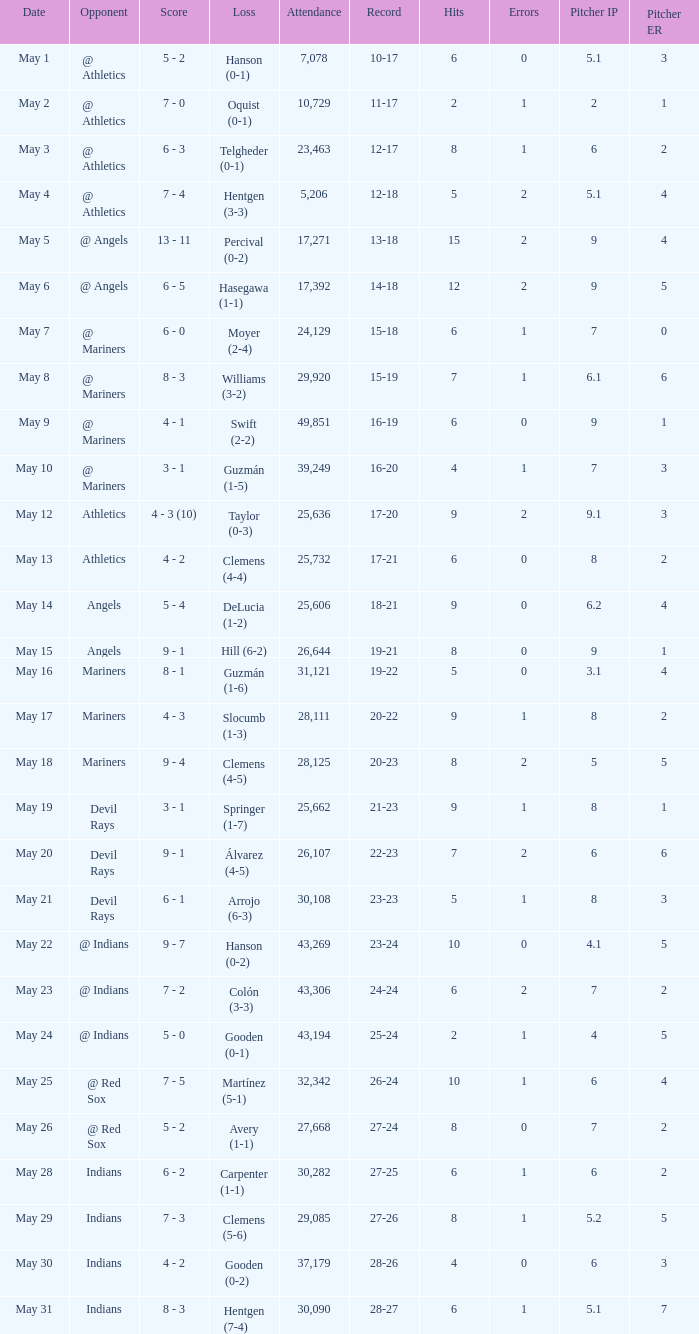What is the record for May 31? 28-27. 